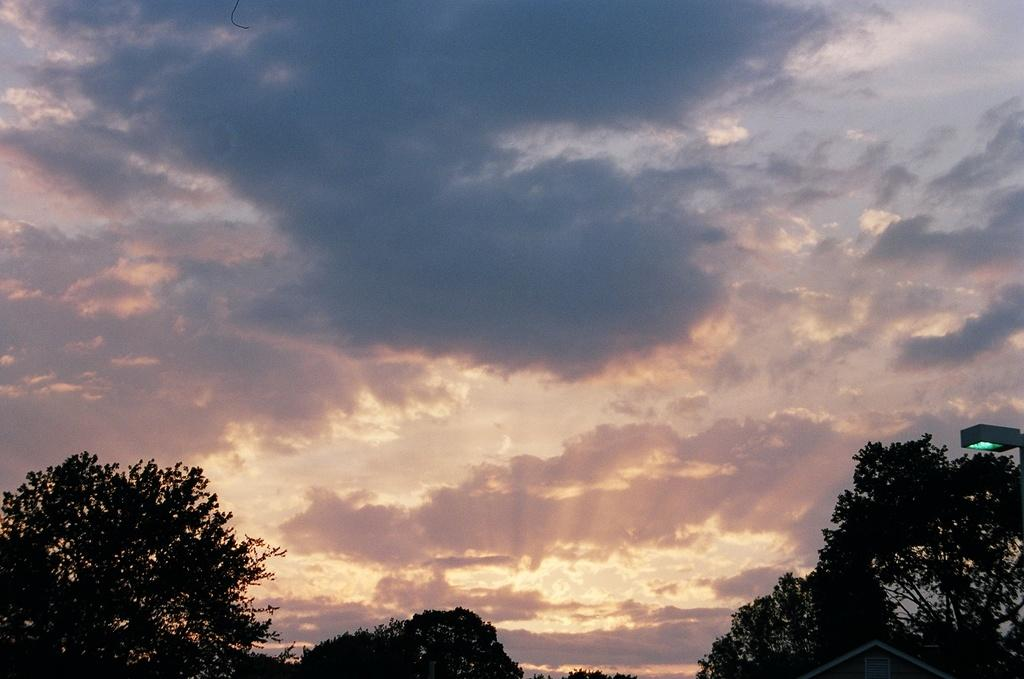What is the condition of the sky in the image? The sky is cloudy in the image. What type of natural vegetation can be seen in the image? There are trees visible in the image. How many cents are visible on the tree in the image? There are no cents present in the image; it features a cloudy sky and trees. What type of thrill can be experienced while observing the quince in the image? There is no quince present in the image, and therefore no such thrill can be experienced. 